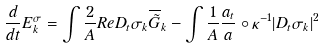Convert formula to latex. <formula><loc_0><loc_0><loc_500><loc_500>\frac { d } { d t } E _ { k } ^ { \sigma } = \int \frac { 2 } { A } R e D _ { t } \sigma _ { k } \overline { \tilde { G } } _ { k } - \int \frac { 1 } { A } \frac { a _ { t } } { a } \circ \kappa ^ { - 1 } | D _ { t } \sigma _ { k } | ^ { 2 }</formula> 